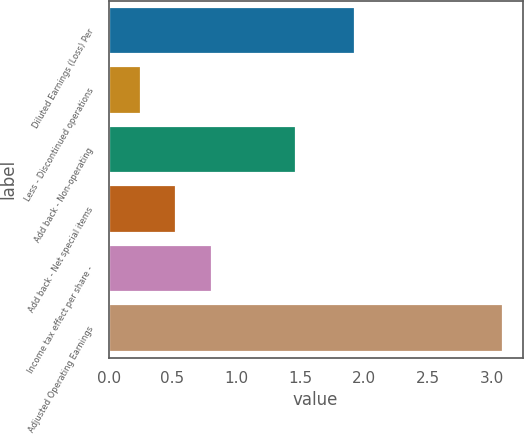Convert chart. <chart><loc_0><loc_0><loc_500><loc_500><bar_chart><fcel>Diluted Earnings (Loss) Per<fcel>Less - Discontinued operations<fcel>Add back - Non-operating<fcel>Add back - Net special items<fcel>Income tax effect per share -<fcel>Adjusted Operating Earnings<nl><fcel>1.93<fcel>0.25<fcel>1.47<fcel>0.53<fcel>0.81<fcel>3.09<nl></chart> 